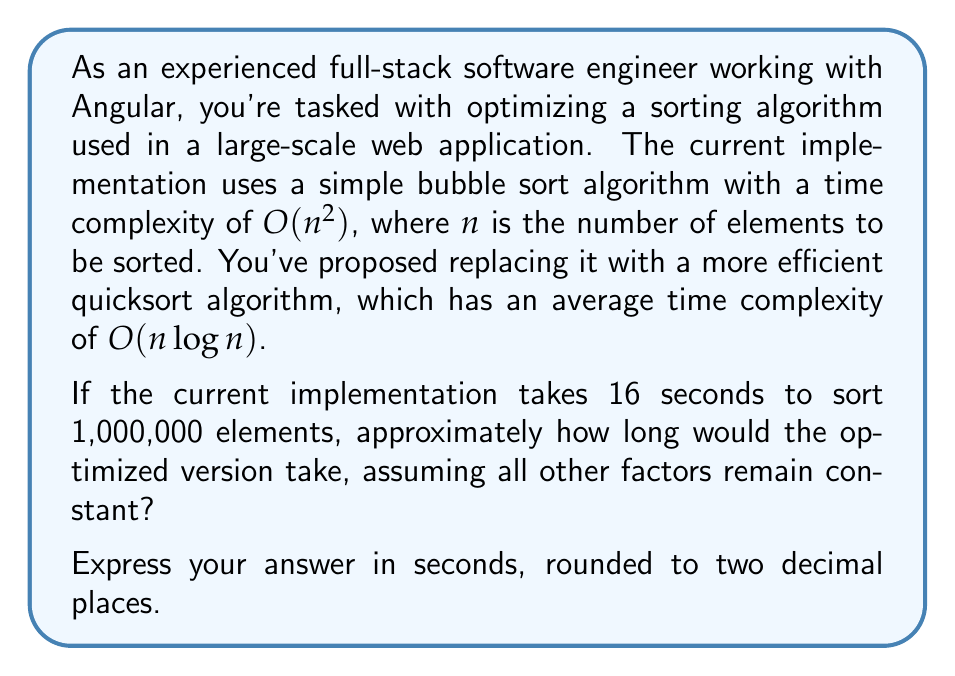Provide a solution to this math problem. To solve this problem, we need to use logarithmic comparisons to analyze the efficiency improvement. Let's break it down step-by-step:

1) First, let's establish the relationship between the two algorithms:
   
   Bubble sort: $T_1(n) = k_1 n^2$
   Quicksort: $T_2(n) = k_2 n \log n$

   Where $k_1$ and $k_2$ are constants depending on the implementation and hardware.

2) We know that for $n = 1,000,000$, $T_1(n) = 16$ seconds. Let's use this to find $k_1$:

   $16 = k_1 \cdot (1,000,000)^2$
   $k_1 = \frac{16}{10^{12}} = 1.6 \times 10^{-11}$

3) Now, we need to find $k_2$. We can assume that the constant factors are similar for both algorithms, so $k_1 \approx k_2$. This is a simplification, but it allows us to make a reasonable estimate.

4) Using $k_2 = 1.6 \times 10^{-11}$, we can now calculate $T_2(n)$:

   $T_2(n) = 1.6 \times 10^{-11} \cdot 1,000,000 \cdot \log(1,000,000)$

5) $\log(1,000,000) = \log(10^6) = 6 \log(10) \approx 13.8155$ (using natural logarithm)

6) Plugging this in:

   $T_2(n) = 1.6 \times 10^{-11} \cdot 1,000,000 \cdot 13.8155$
   $T_2(n) = 0.221048$ seconds

7) Rounding to two decimal places: 0.22 seconds
Answer: 0.22 seconds 